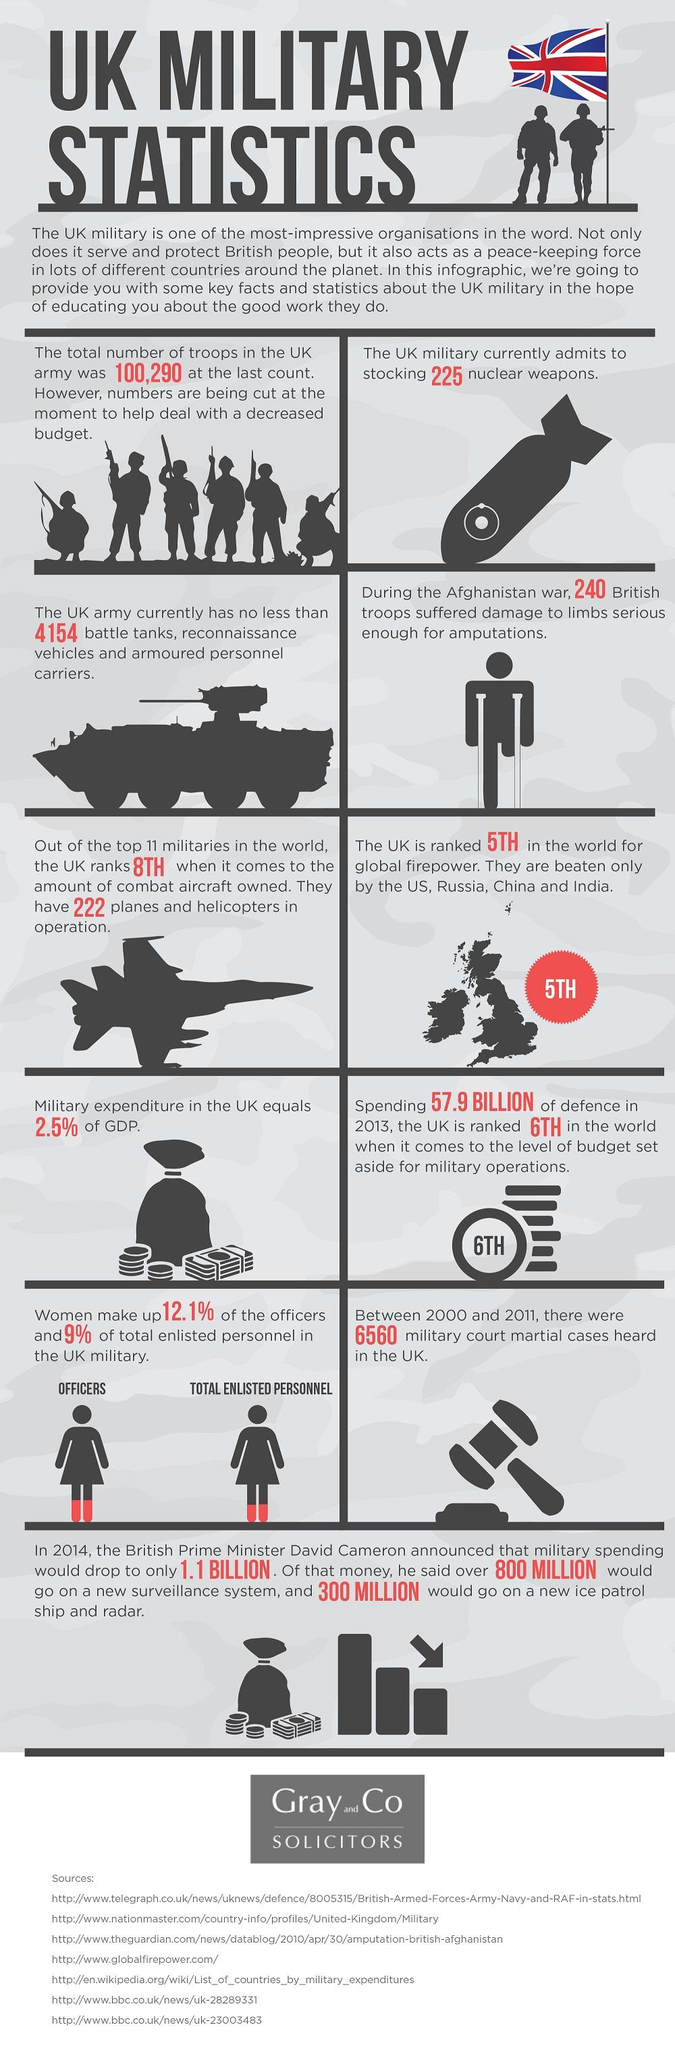Mention a couple of crucial points in this snapshot. There are a total of 7 sources listed. 